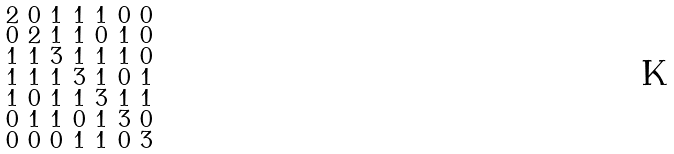<formula> <loc_0><loc_0><loc_500><loc_500>\begin{smallmatrix} 2 & 0 & 1 & 1 & 1 & 0 & 0 \\ 0 & 2 & 1 & 1 & 0 & 1 & 0 \\ 1 & 1 & 3 & 1 & 1 & 1 & 0 \\ 1 & 1 & 1 & 3 & 1 & 0 & 1 \\ 1 & 0 & 1 & 1 & 3 & 1 & 1 \\ 0 & 1 & 1 & 0 & 1 & 3 & 0 \\ 0 & 0 & 0 & 1 & 1 & 0 & 3 \end{smallmatrix}</formula> 